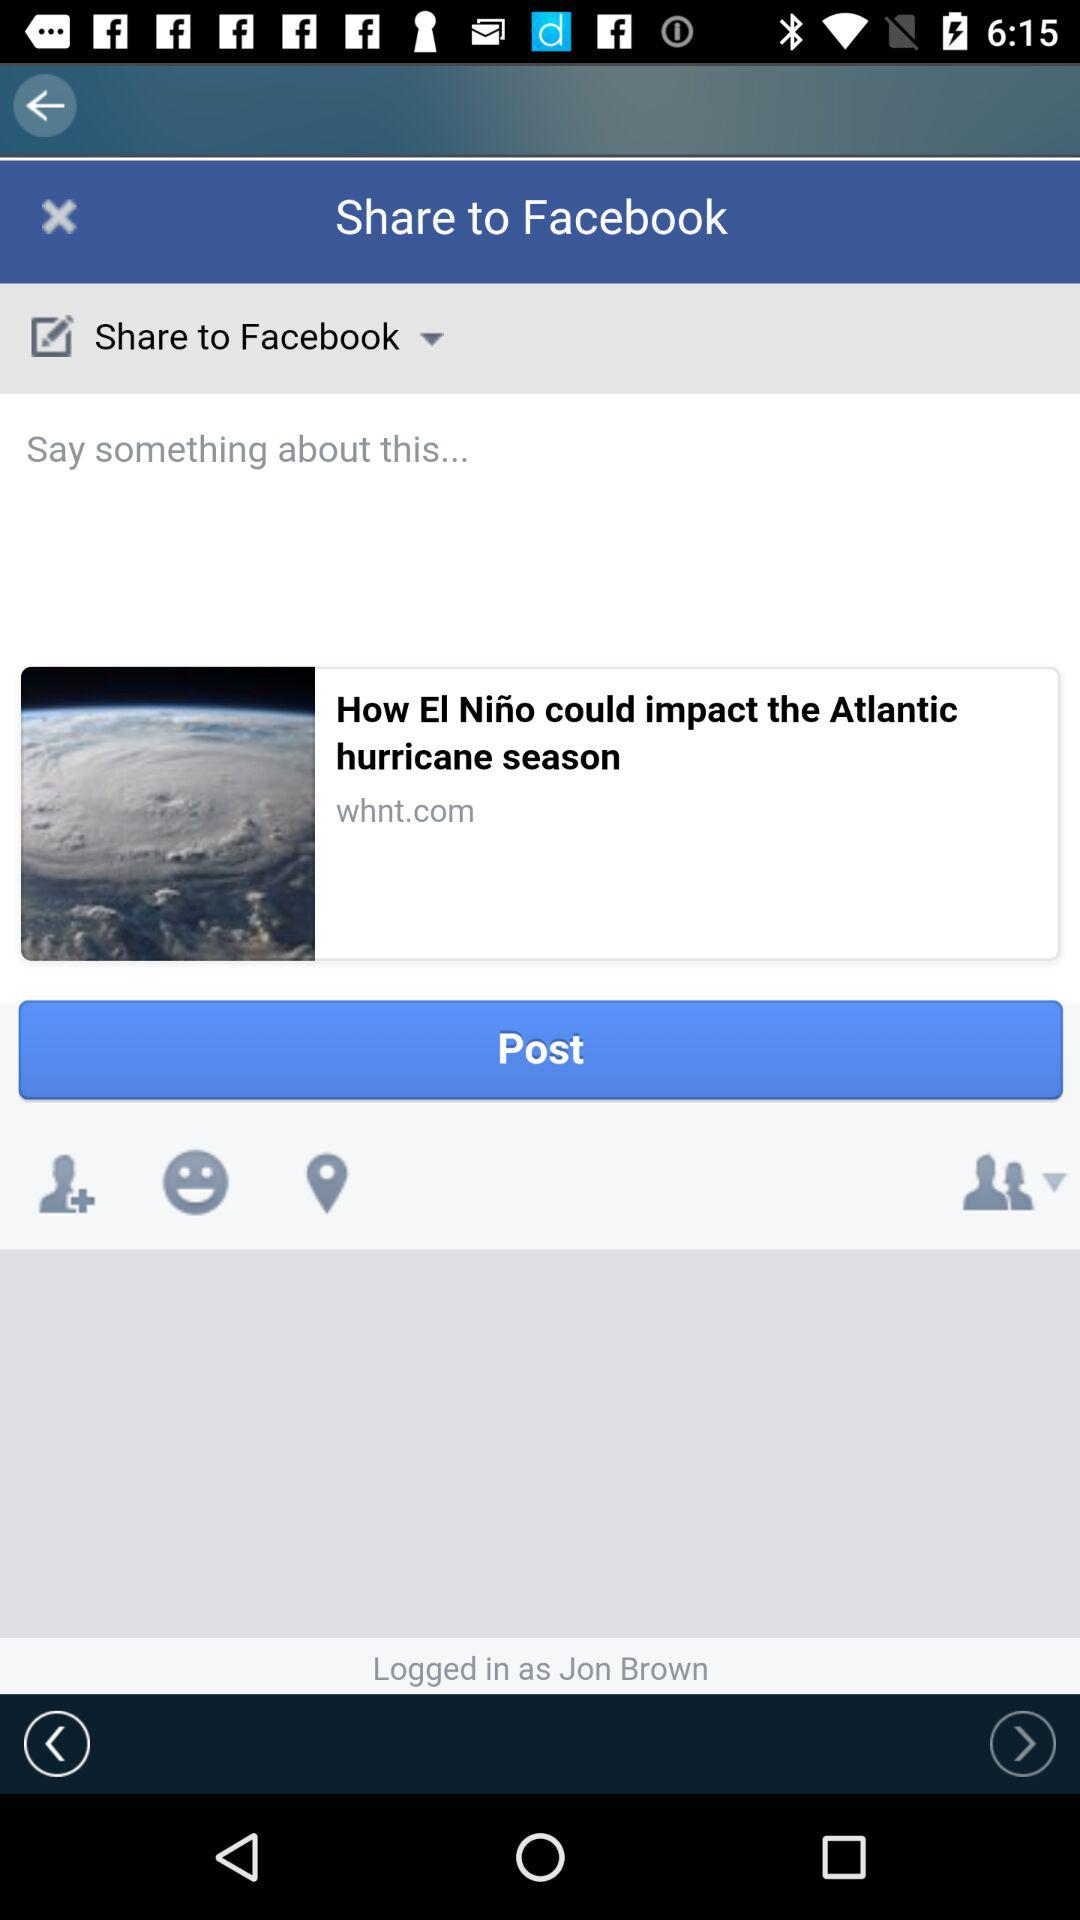What is the name of the user? The name of the user is Jon Brown. 